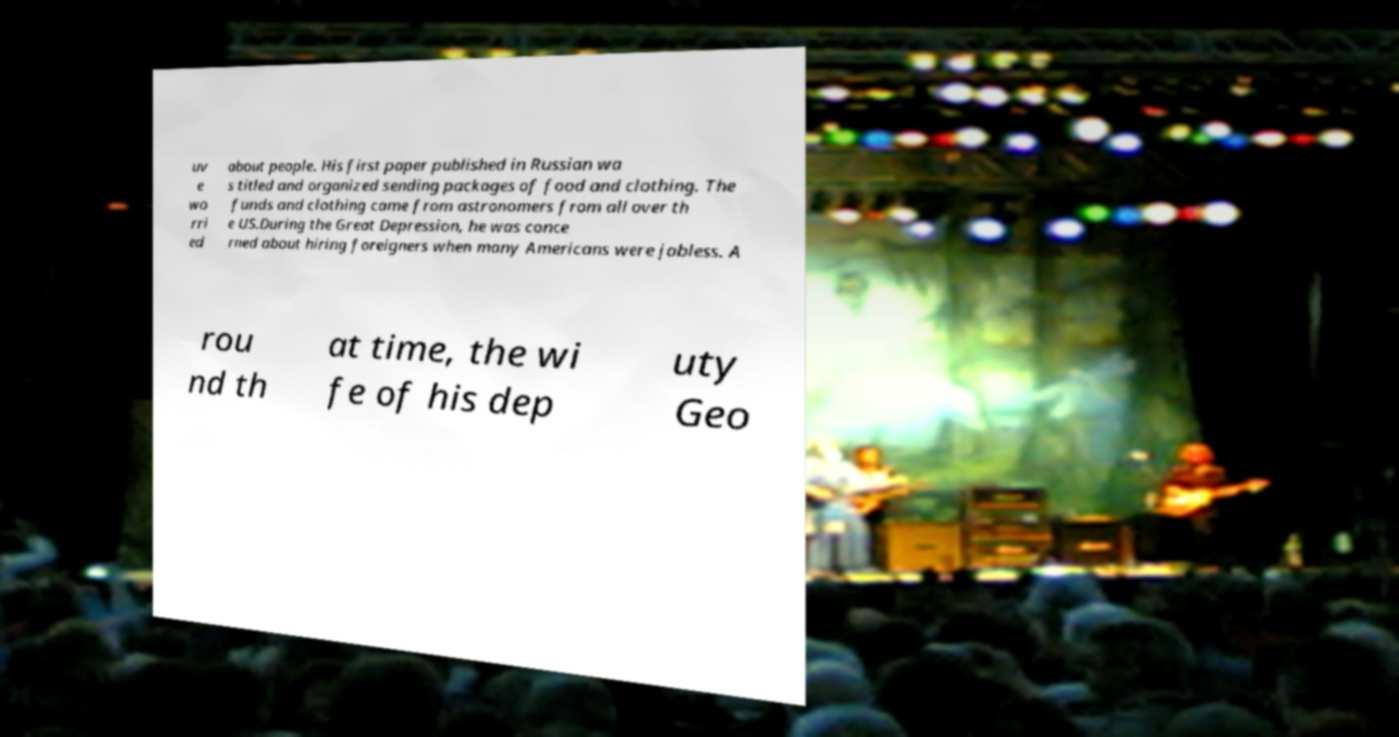Can you accurately transcribe the text from the provided image for me? uv e wo rri ed about people. His first paper published in Russian wa s titled and organized sending packages of food and clothing. The funds and clothing came from astronomers from all over th e US.During the Great Depression, he was conce rned about hiring foreigners when many Americans were jobless. A rou nd th at time, the wi fe of his dep uty Geo 